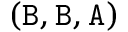<formula> <loc_0><loc_0><loc_500><loc_500>( B , B , A )</formula> 